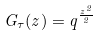Convert formula to latex. <formula><loc_0><loc_0><loc_500><loc_500>G _ { \tau } ( z ) = q ^ { \frac { z ^ { 2 } } { 2 } }</formula> 